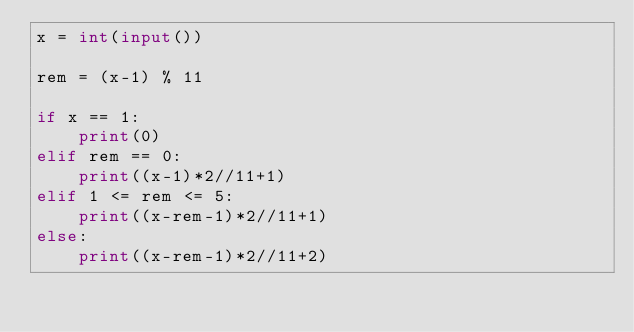Convert code to text. <code><loc_0><loc_0><loc_500><loc_500><_Python_>x = int(input())

rem = (x-1) % 11

if x == 1:
    print(0)
elif rem == 0:
    print((x-1)*2//11+1)
elif 1 <= rem <= 5:
    print((x-rem-1)*2//11+1)
else:
    print((x-rem-1)*2//11+2)
</code> 